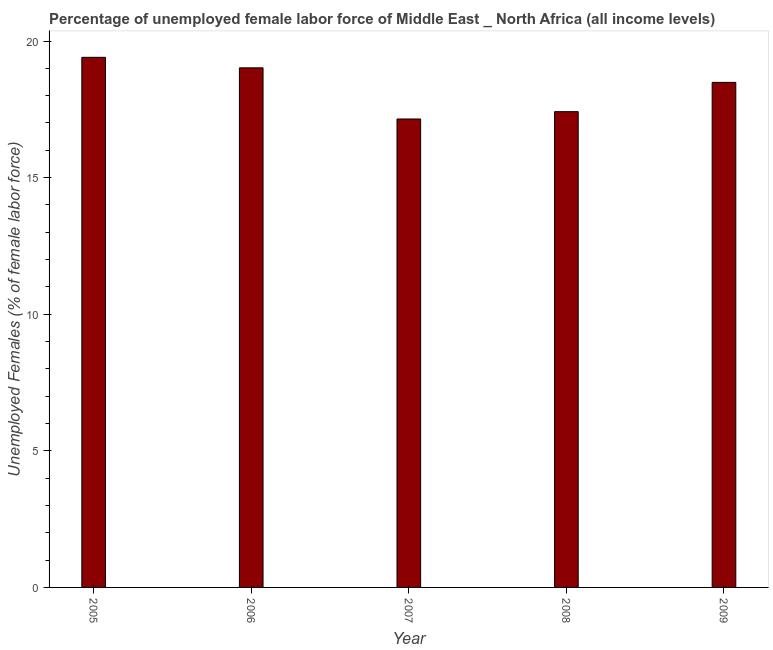What is the title of the graph?
Keep it short and to the point. Percentage of unemployed female labor force of Middle East _ North Africa (all income levels). What is the label or title of the X-axis?
Your answer should be very brief. Year. What is the label or title of the Y-axis?
Keep it short and to the point. Unemployed Females (% of female labor force). What is the total unemployed female labour force in 2008?
Make the answer very short. 17.41. Across all years, what is the maximum total unemployed female labour force?
Provide a succinct answer. 19.4. Across all years, what is the minimum total unemployed female labour force?
Keep it short and to the point. 17.15. In which year was the total unemployed female labour force minimum?
Offer a very short reply. 2007. What is the sum of the total unemployed female labour force?
Provide a succinct answer. 91.47. What is the difference between the total unemployed female labour force in 2005 and 2009?
Offer a terse response. 0.92. What is the average total unemployed female labour force per year?
Your answer should be compact. 18.29. What is the median total unemployed female labour force?
Give a very brief answer. 18.49. In how many years, is the total unemployed female labour force greater than 16 %?
Make the answer very short. 5. What is the ratio of the total unemployed female labour force in 2005 to that in 2007?
Provide a succinct answer. 1.13. Is the total unemployed female labour force in 2005 less than that in 2008?
Your answer should be compact. No. Is the difference between the total unemployed female labour force in 2006 and 2009 greater than the difference between any two years?
Provide a short and direct response. No. What is the difference between the highest and the second highest total unemployed female labour force?
Your answer should be very brief. 0.39. What is the difference between the highest and the lowest total unemployed female labour force?
Keep it short and to the point. 2.26. In how many years, is the total unemployed female labour force greater than the average total unemployed female labour force taken over all years?
Offer a terse response. 3. Are all the bars in the graph horizontal?
Keep it short and to the point. No. What is the difference between two consecutive major ticks on the Y-axis?
Give a very brief answer. 5. What is the Unemployed Females (% of female labor force) in 2005?
Make the answer very short. 19.4. What is the Unemployed Females (% of female labor force) of 2006?
Provide a short and direct response. 19.02. What is the Unemployed Females (% of female labor force) in 2007?
Your answer should be very brief. 17.15. What is the Unemployed Females (% of female labor force) in 2008?
Make the answer very short. 17.41. What is the Unemployed Females (% of female labor force) in 2009?
Your response must be concise. 18.49. What is the difference between the Unemployed Females (% of female labor force) in 2005 and 2006?
Provide a short and direct response. 0.38. What is the difference between the Unemployed Females (% of female labor force) in 2005 and 2007?
Provide a succinct answer. 2.26. What is the difference between the Unemployed Females (% of female labor force) in 2005 and 2008?
Keep it short and to the point. 1.99. What is the difference between the Unemployed Females (% of female labor force) in 2005 and 2009?
Make the answer very short. 0.92. What is the difference between the Unemployed Females (% of female labor force) in 2006 and 2007?
Ensure brevity in your answer.  1.87. What is the difference between the Unemployed Females (% of female labor force) in 2006 and 2008?
Keep it short and to the point. 1.6. What is the difference between the Unemployed Females (% of female labor force) in 2006 and 2009?
Provide a succinct answer. 0.53. What is the difference between the Unemployed Females (% of female labor force) in 2007 and 2008?
Your answer should be compact. -0.27. What is the difference between the Unemployed Females (% of female labor force) in 2007 and 2009?
Provide a short and direct response. -1.34. What is the difference between the Unemployed Females (% of female labor force) in 2008 and 2009?
Your response must be concise. -1.07. What is the ratio of the Unemployed Females (% of female labor force) in 2005 to that in 2006?
Offer a terse response. 1.02. What is the ratio of the Unemployed Females (% of female labor force) in 2005 to that in 2007?
Your answer should be very brief. 1.13. What is the ratio of the Unemployed Females (% of female labor force) in 2005 to that in 2008?
Ensure brevity in your answer.  1.11. What is the ratio of the Unemployed Females (% of female labor force) in 2006 to that in 2007?
Give a very brief answer. 1.11. What is the ratio of the Unemployed Females (% of female labor force) in 2006 to that in 2008?
Provide a short and direct response. 1.09. What is the ratio of the Unemployed Females (% of female labor force) in 2007 to that in 2009?
Ensure brevity in your answer.  0.93. What is the ratio of the Unemployed Females (% of female labor force) in 2008 to that in 2009?
Offer a very short reply. 0.94. 